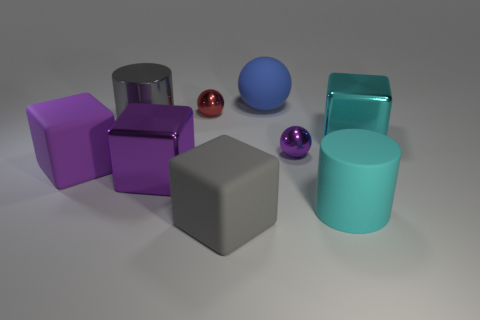How big is the cyan shiny object?
Ensure brevity in your answer.  Large. What is the material of the object that is the same color as the big matte cylinder?
Provide a short and direct response. Metal. Is the size of the purple rubber block the same as the red metallic thing?
Offer a very short reply. No. How many big things are either matte spheres or red metallic spheres?
Provide a succinct answer. 1. Is there any other thing of the same color as the big matte cylinder?
Offer a terse response. Yes. What is the material of the large thing that is behind the metallic ball that is left of the tiny metallic object that is right of the small red metal ball?
Your answer should be compact. Rubber. What number of matte things are either big blue spheres or large things?
Your response must be concise. 4. What number of blue objects are either large shiny balls or matte balls?
Make the answer very short. 1. There is a rubber block in front of the big purple shiny thing; does it have the same color as the metallic cylinder?
Your answer should be compact. Yes. Does the tiny purple sphere have the same material as the large cyan cylinder?
Your answer should be very brief. No. 